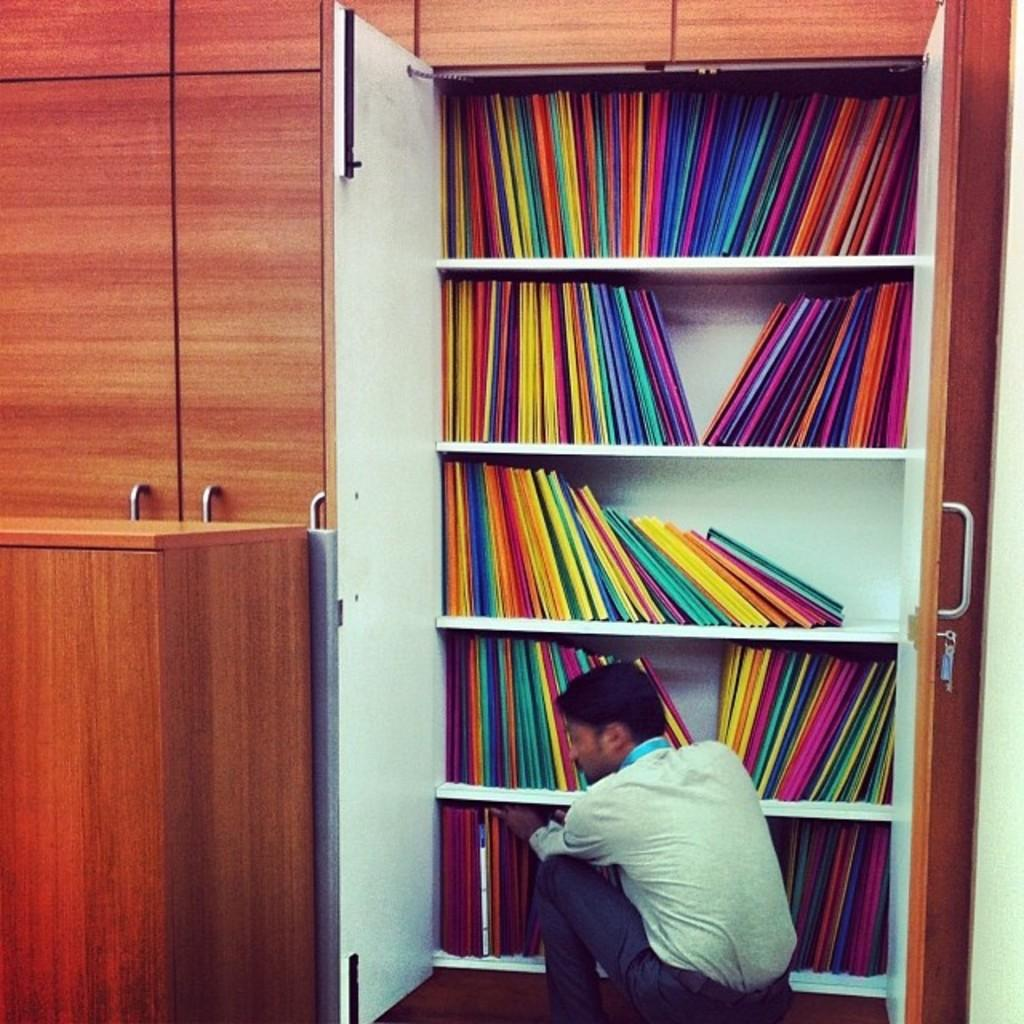What can be seen inside the cupboard in the image? There are colorful objects in the cupboard. Who is standing in front of the cupboard? There is a person with a dress in front of the cupboard. What is the color of the object to the left of the person? There is a brown color object to the left. How many feet does the person have in the image? The number of feet the person has cannot be determined from the image, as feet are not visible. 